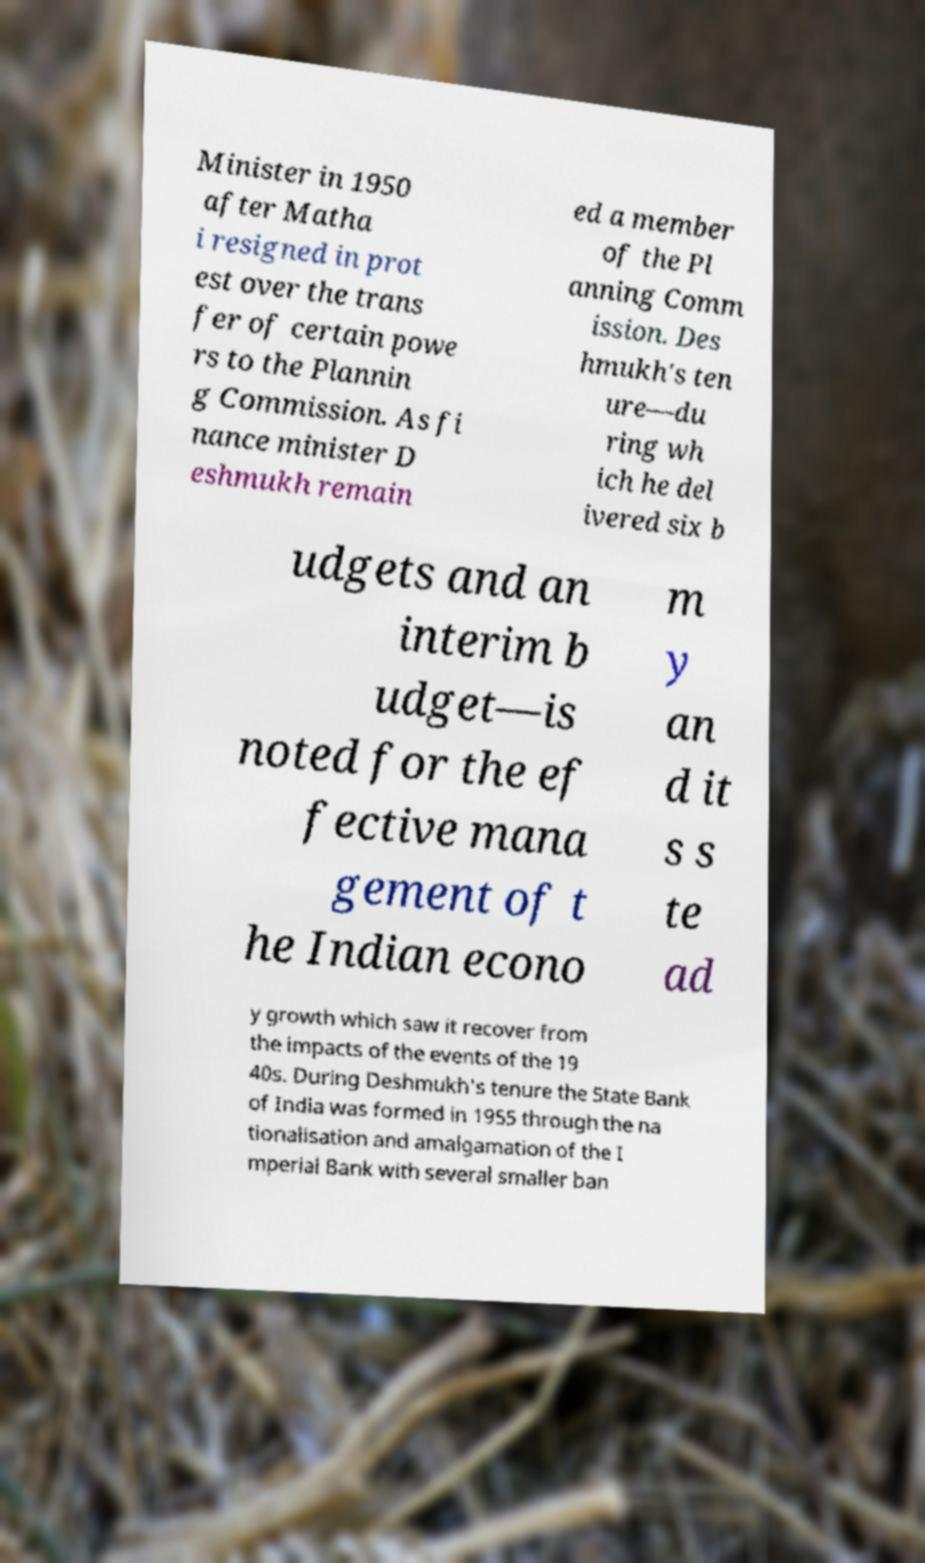Can you accurately transcribe the text from the provided image for me? Minister in 1950 after Matha i resigned in prot est over the trans fer of certain powe rs to the Plannin g Commission. As fi nance minister D eshmukh remain ed a member of the Pl anning Comm ission. Des hmukh's ten ure—du ring wh ich he del ivered six b udgets and an interim b udget—is noted for the ef fective mana gement of t he Indian econo m y an d it s s te ad y growth which saw it recover from the impacts of the events of the 19 40s. During Deshmukh's tenure the State Bank of India was formed in 1955 through the na tionalisation and amalgamation of the I mperial Bank with several smaller ban 